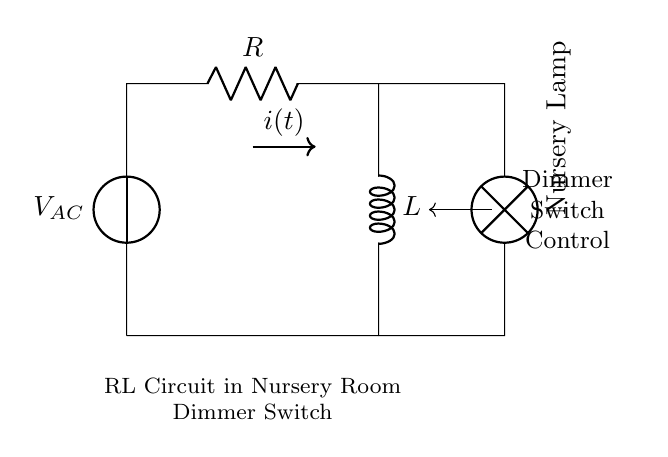What are the components in the circuit? The circuit consists of a voltage source (V_AC), a resistor (R), an inductor (L), and a lamp labeled as the Nursery Lamp.
Answer: voltage source, resistor, inductor, lamp What is the purpose of the dimmer switch in this circuit? The dimmer switch controls the brightness of the nursery lamp by regulating the electrical power supplied to it, allowing for adjustable lighting.
Answer: regulate brightness What is the current denoted as in the circuit? The current is denoted as i(t) in the diagram, indicating that it changes with time.
Answer: i(t) How does the resistor affect the circuit? The resistor limits the current flow and dissipates energy in the form of heat, affecting the overall power consumption in the circuit.
Answer: limits current What is the effect of the inductor on the circuit operation? The inductor stores energy in its magnetic field when current flows through it and causes a delay in the current change when the lights are dimmed or brightened.
Answer: stores energy What happens when the dimmer switch is adjusted to a lower setting? When the dimmer switch is lowered, the circuit allows less current to flow to the lamp, reducing brightness and causing the inductor to resist changes in current flow.
Answer: less current flows Which component contributes to the inductive reactance in this circuit? The inductor (L) contributes to the inductive reactance, which opposes changes in current similar to resistance.
Answer: inductor 